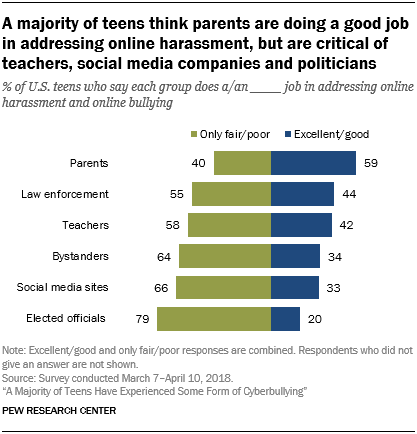Highlight a few significant elements in this photo. The value for elected officials in the "Excellent/Good" category is 20 or higher. The average value of all green bars is 120.67 and the double of this value is 241.34. 